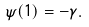Convert formula to latex. <formula><loc_0><loc_0><loc_500><loc_500>\psi ( 1 ) = - \gamma .</formula> 